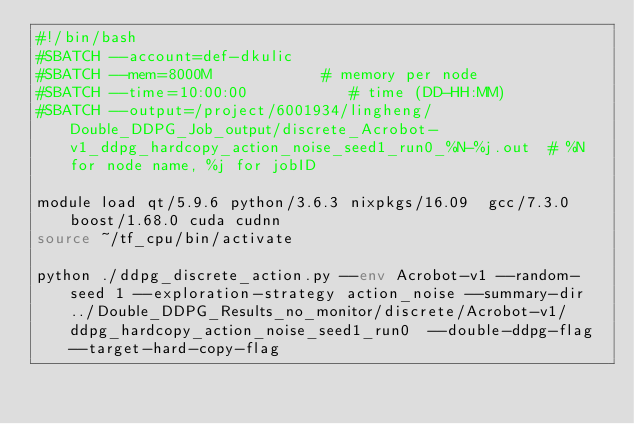Convert code to text. <code><loc_0><loc_0><loc_500><loc_500><_Bash_>#!/bin/bash
#SBATCH --account=def-dkulic
#SBATCH --mem=8000M            # memory per node
#SBATCH --time=10:00:00           # time (DD-HH:MM)
#SBATCH --output=/project/6001934/lingheng/Double_DDPG_Job_output/discrete_Acrobot-v1_ddpg_hardcopy_action_noise_seed1_run0_%N-%j.out  # %N for node name, %j for jobID

module load qt/5.9.6 python/3.6.3 nixpkgs/16.09  gcc/7.3.0 boost/1.68.0 cuda cudnn
source ~/tf_cpu/bin/activate

python ./ddpg_discrete_action.py --env Acrobot-v1 --random-seed 1 --exploration-strategy action_noise --summary-dir ../Double_DDPG_Results_no_monitor/discrete/Acrobot-v1/ddpg_hardcopy_action_noise_seed1_run0  --double-ddpg-flag --target-hard-copy-flag 

</code> 